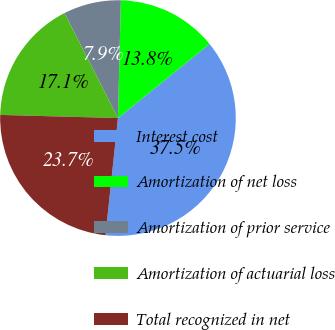Convert chart to OTSL. <chart><loc_0><loc_0><loc_500><loc_500><pie_chart><fcel>Interest cost<fcel>Amortization of net loss<fcel>Amortization of prior service<fcel>Amortization of actuarial loss<fcel>Total recognized in net<nl><fcel>37.52%<fcel>13.78%<fcel>7.89%<fcel>17.08%<fcel>23.74%<nl></chart> 